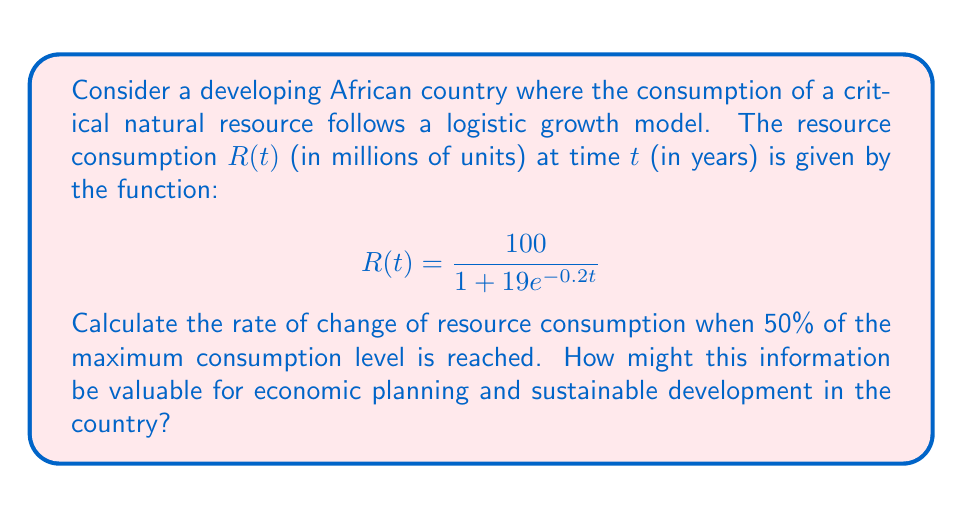What is the answer to this math problem? To solve this problem, we'll follow these steps:

1) First, identify the maximum consumption level (carrying capacity) from the given logistic function:
   $$R(t) = \frac{100}{1 + 19e^{-0.2t}}$$
   The maximum level is 100 million units.

2) We need to find the rate of change when 50% of the maximum is reached, which is 50 million units.

3) To find the rate of change, we need to differentiate $R(t)$ with respect to $t$:
   $$R'(t) = \frac{d}{dt}\left(\frac{100}{1 + 19e^{-0.2t}}\right)$$
   
   Using the quotient rule:
   $$R'(t) = \frac{100 \cdot 19 \cdot 0.2 \cdot e^{-0.2t}}{(1 + 19e^{-0.2t})^2}$$
   
   Simplifying:
   $$R'(t) = \frac{380e^{-0.2t}}{(1 + 19e^{-0.2t})^2}$$

4) Now, we need to find when $R(t) = 50$:
   $$50 = \frac{100}{1 + 19e^{-0.2t}}$$
   
   Solving for $e^{-0.2t}$:
   $$e^{-0.2t} = 1$$
   
   This occurs when $t = 0$.

5) Substitute $t = 0$ into $R'(t)$:
   $$R'(0) = \frac{380 \cdot 1}{(1 + 19 \cdot 1)^2} = \frac{380}{400} = 0.95$$

Therefore, when the resource consumption reaches 50% of its maximum level, it is increasing at a rate of 0.95 million units per year.

This information is valuable for economic planning and sustainable development because it indicates the point of maximum growth rate in resource consumption. Policymakers can use this to anticipate when resource demand will be increasing most rapidly, allowing them to plan for infrastructure development, resource management, and potential environmental impacts. It also helps in forecasting economic growth and potential resource constraints, which is crucial for long-term sustainable development strategies.
Answer: 0.95 million units per year 